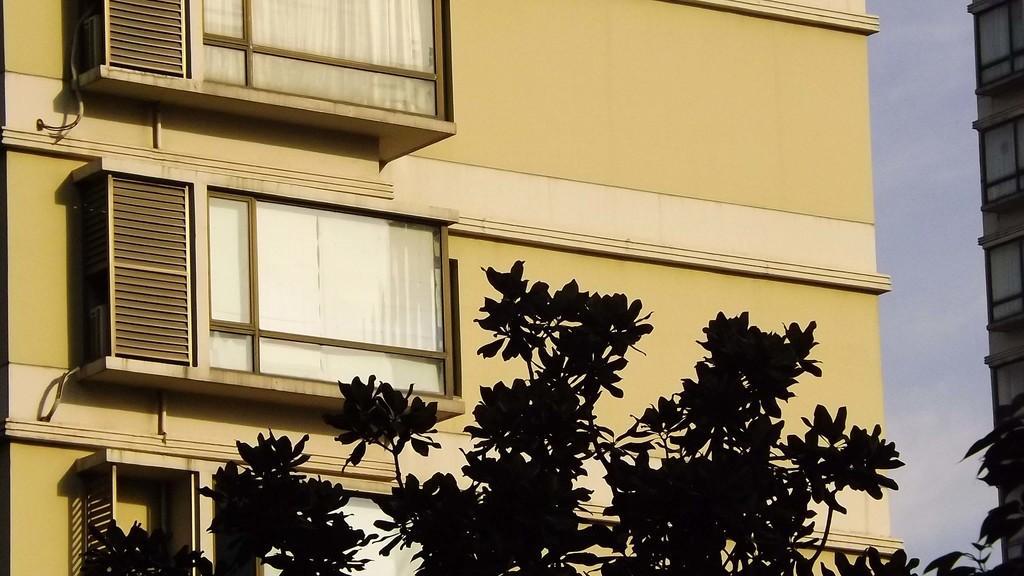Please provide a concise description of this image. In this image we can see buildings, trees, sky and clouds. 